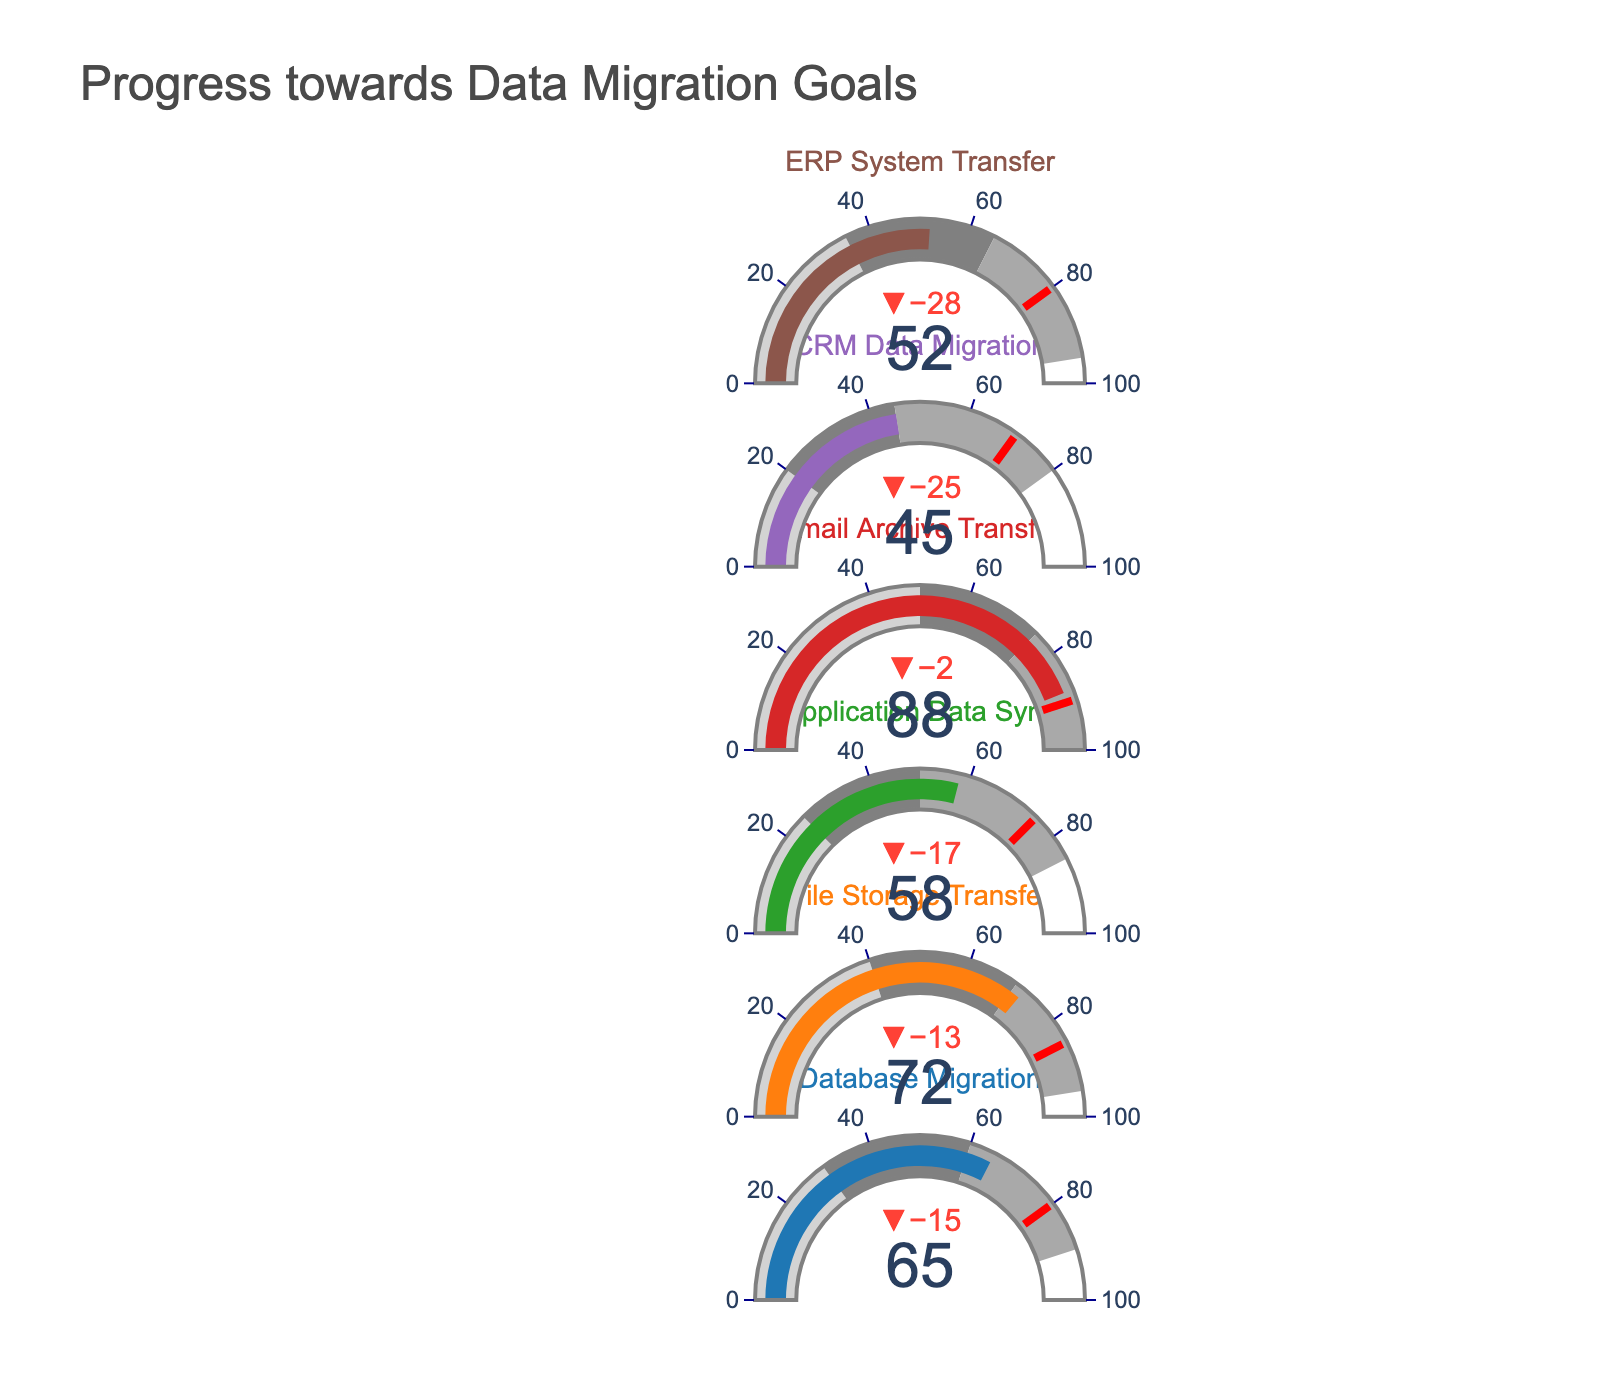What is the target value for the Email Archive Transfer category? The target value for the Email Archive Transfer category can be found as part of the data displayed on the chart. Each category has a target displayed as a red threshold line.
Answer: 90 Which category has the highest percentage of data transferred? To find the category with the highest percentage of data transferred, compare the 'Actual' values for each category. The highest percentage corresponds to Email Archive Transfer with an actual value of 88%.
Answer: Email Archive Transfer How does the CRM Data Migration's progress compare to its target? Compare the actual value of CRM Data Migration (45%) with its target value (70%). The actual is 25% less than the target.
Answer: 25% less Which category is closest to reaching its target percentage-wise? To determine which category is closest to its target, compute the difference between the 'Actual' and 'Target' for each category. The category with the smallest difference in percentage is Email Archive Transfer (actual 88, target 90, difference 2).
Answer: Email Archive Transfer Calculate the average percentage of data transferred for Application Data Sync, CRM Data Migration, and ERP System Transfer. Sum the actual values for these categories (58, 45, and 52) and divide by the number of categories (3): (58 + 45 + 52)/3 = 51.67
Answer: 51.67 Which categories have achieved more than 70% of their target? Identify categories where the actual value is more than 70% of the target. The categories within this range are File Storage Transfer (actual 72, target 85, percentage 84.7%) and Email Archive Transfer (actual 88, target 90, percentage 97.8%).
Answer: File Storage Transfer, Email Archive Transfer Among all categories, which ones fall into the second progress range (gray)? The second progress range is labeled gray and covers specific percentages for each category. File Storage Transfer, CRM Data Migration, and ERP System Transfer's actuals fall into this range (72, 45, and 52, respectively).
Answer: File Storage Transfer, CRM Data Migration, ERP System Transfer If the company reaches their targets by the deadline, what is the total percentage of data to be migrated? Sum the target values for each category: 80 + 85 + 75 + 90 + 70 + 80 = 480
Answer: 480 What is the difference between the actual and target values for Database Migration? Subtract the actual value from the target value for Database Migration (80 - 65 = 15).
Answer: 15 Identify the category with the lowest actual percentage of data transferred. To find the category with the lowest actual percentage, look at the 'Actual' values and identify the smallest one, which is CRM Data Migration at 45%.
Answer: CRM Data Migration 